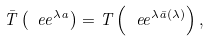Convert formula to latex. <formula><loc_0><loc_0><loc_500><loc_500>\bar { T } \left ( \ e e ^ { \lambda a } \right ) = T \left ( \ e e ^ { \lambda \bar { a } ( \lambda ) } \right ) ,</formula> 